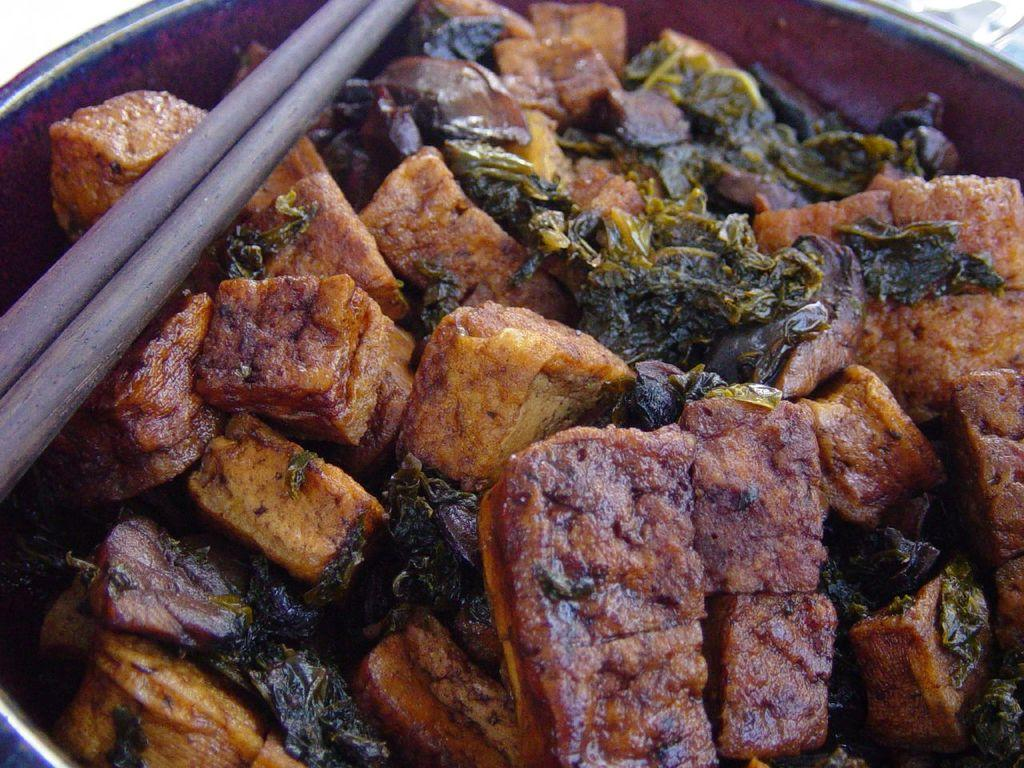What type of food item is in the bowl in the image? The facts do not specify the type of food item in the bowl. What is placed on the bowl in the image? There are two sticks placed on the bowl in the image. How many balls are visible in the wilderness in the image? There are no balls or wilderness present in the image; it only features a food item in a bowl with two sticks placed on it. 